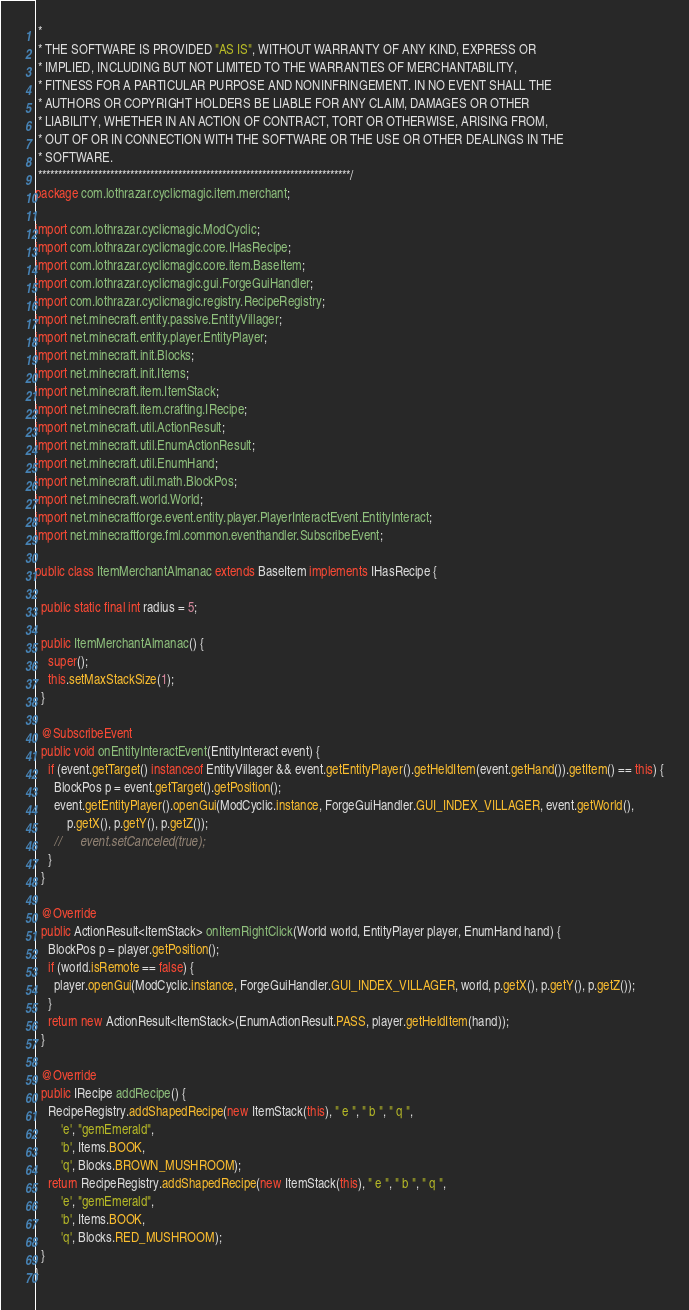Convert code to text. <code><loc_0><loc_0><loc_500><loc_500><_Java_> * 
 * THE SOFTWARE IS PROVIDED "AS IS", WITHOUT WARRANTY OF ANY KIND, EXPRESS OR
 * IMPLIED, INCLUDING BUT NOT LIMITED TO THE WARRANTIES OF MERCHANTABILITY,
 * FITNESS FOR A PARTICULAR PURPOSE AND NONINFRINGEMENT. IN NO EVENT SHALL THE
 * AUTHORS OR COPYRIGHT HOLDERS BE LIABLE FOR ANY CLAIM, DAMAGES OR OTHER
 * LIABILITY, WHETHER IN AN ACTION OF CONTRACT, TORT OR OTHERWISE, ARISING FROM,
 * OUT OF OR IN CONNECTION WITH THE SOFTWARE OR THE USE OR OTHER DEALINGS IN THE
 * SOFTWARE.
 ******************************************************************************/
package com.lothrazar.cyclicmagic.item.merchant;

import com.lothrazar.cyclicmagic.ModCyclic;
import com.lothrazar.cyclicmagic.core.IHasRecipe;
import com.lothrazar.cyclicmagic.core.item.BaseItem;
import com.lothrazar.cyclicmagic.gui.ForgeGuiHandler;
import com.lothrazar.cyclicmagic.registry.RecipeRegistry;
import net.minecraft.entity.passive.EntityVillager;
import net.minecraft.entity.player.EntityPlayer;
import net.minecraft.init.Blocks;
import net.minecraft.init.Items;
import net.minecraft.item.ItemStack;
import net.minecraft.item.crafting.IRecipe;
import net.minecraft.util.ActionResult;
import net.minecraft.util.EnumActionResult;
import net.minecraft.util.EnumHand;
import net.minecraft.util.math.BlockPos;
import net.minecraft.world.World;
import net.minecraftforge.event.entity.player.PlayerInteractEvent.EntityInteract;
import net.minecraftforge.fml.common.eventhandler.SubscribeEvent;

public class ItemMerchantAlmanac extends BaseItem implements IHasRecipe {

  public static final int radius = 5;

  public ItemMerchantAlmanac() {
    super();
    this.setMaxStackSize(1);
  }

  @SubscribeEvent
  public void onEntityInteractEvent(EntityInteract event) {
    if (event.getTarget() instanceof EntityVillager && event.getEntityPlayer().getHeldItem(event.getHand()).getItem() == this) {
      BlockPos p = event.getTarget().getPosition();
      event.getEntityPlayer().openGui(ModCyclic.instance, ForgeGuiHandler.GUI_INDEX_VILLAGER, event.getWorld(),
          p.getX(), p.getY(), p.getZ());
      //      event.setCanceled(true);
    }
  }

  @Override
  public ActionResult<ItemStack> onItemRightClick(World world, EntityPlayer player, EnumHand hand) {
    BlockPos p = player.getPosition();
    if (world.isRemote == false) {
      player.openGui(ModCyclic.instance, ForgeGuiHandler.GUI_INDEX_VILLAGER, world, p.getX(), p.getY(), p.getZ());
    }
    return new ActionResult<ItemStack>(EnumActionResult.PASS, player.getHeldItem(hand));
  }

  @Override
  public IRecipe addRecipe() {
    RecipeRegistry.addShapedRecipe(new ItemStack(this), " e ", " b ", " q ",
        'e', "gemEmerald",
        'b', Items.BOOK,
        'q', Blocks.BROWN_MUSHROOM);
    return RecipeRegistry.addShapedRecipe(new ItemStack(this), " e ", " b ", " q ",
        'e', "gemEmerald",
        'b', Items.BOOK,
        'q', Blocks.RED_MUSHROOM);
  }
}
</code> 